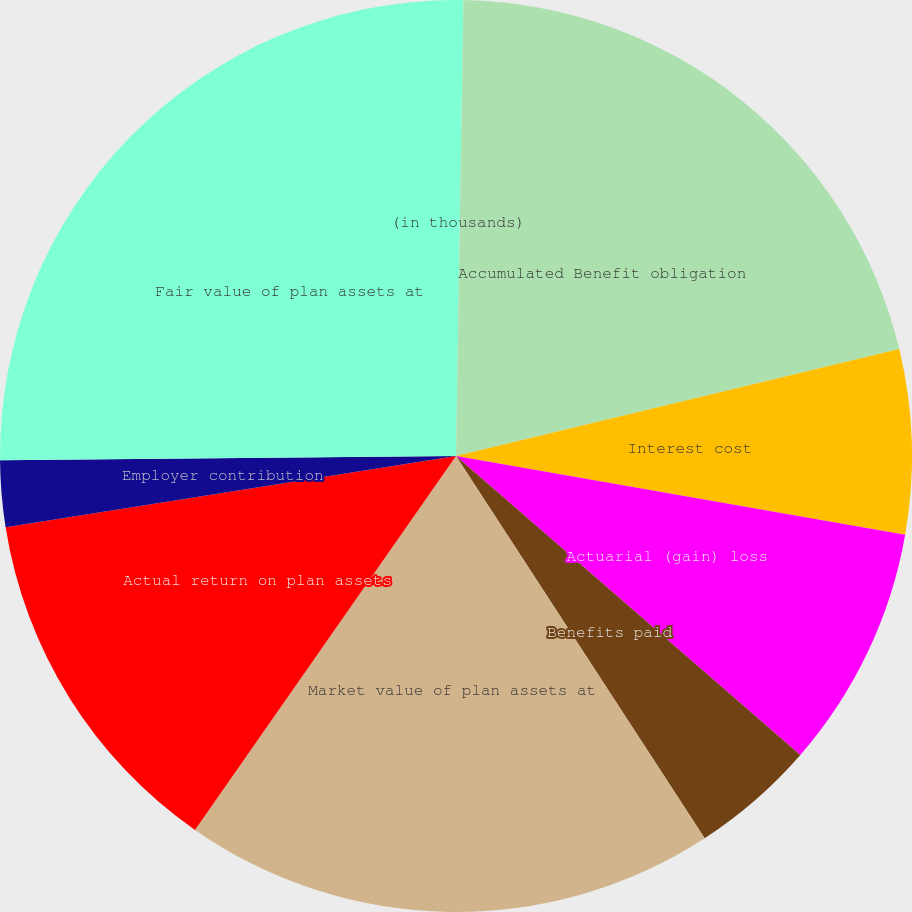<chart> <loc_0><loc_0><loc_500><loc_500><pie_chart><fcel>(in thousands)<fcel>Accumulated Benefit obligation<fcel>Interest cost<fcel>Actuarial (gain) loss<fcel>Benefits paid<fcel>Market value of plan assets at<fcel>Actual return on plan assets<fcel>Employer contribution<fcel>Fair value of plan assets at<nl><fcel>0.26%<fcel>20.97%<fcel>6.53%<fcel>8.62%<fcel>4.44%<fcel>18.88%<fcel>12.8%<fcel>2.35%<fcel>25.15%<nl></chart> 